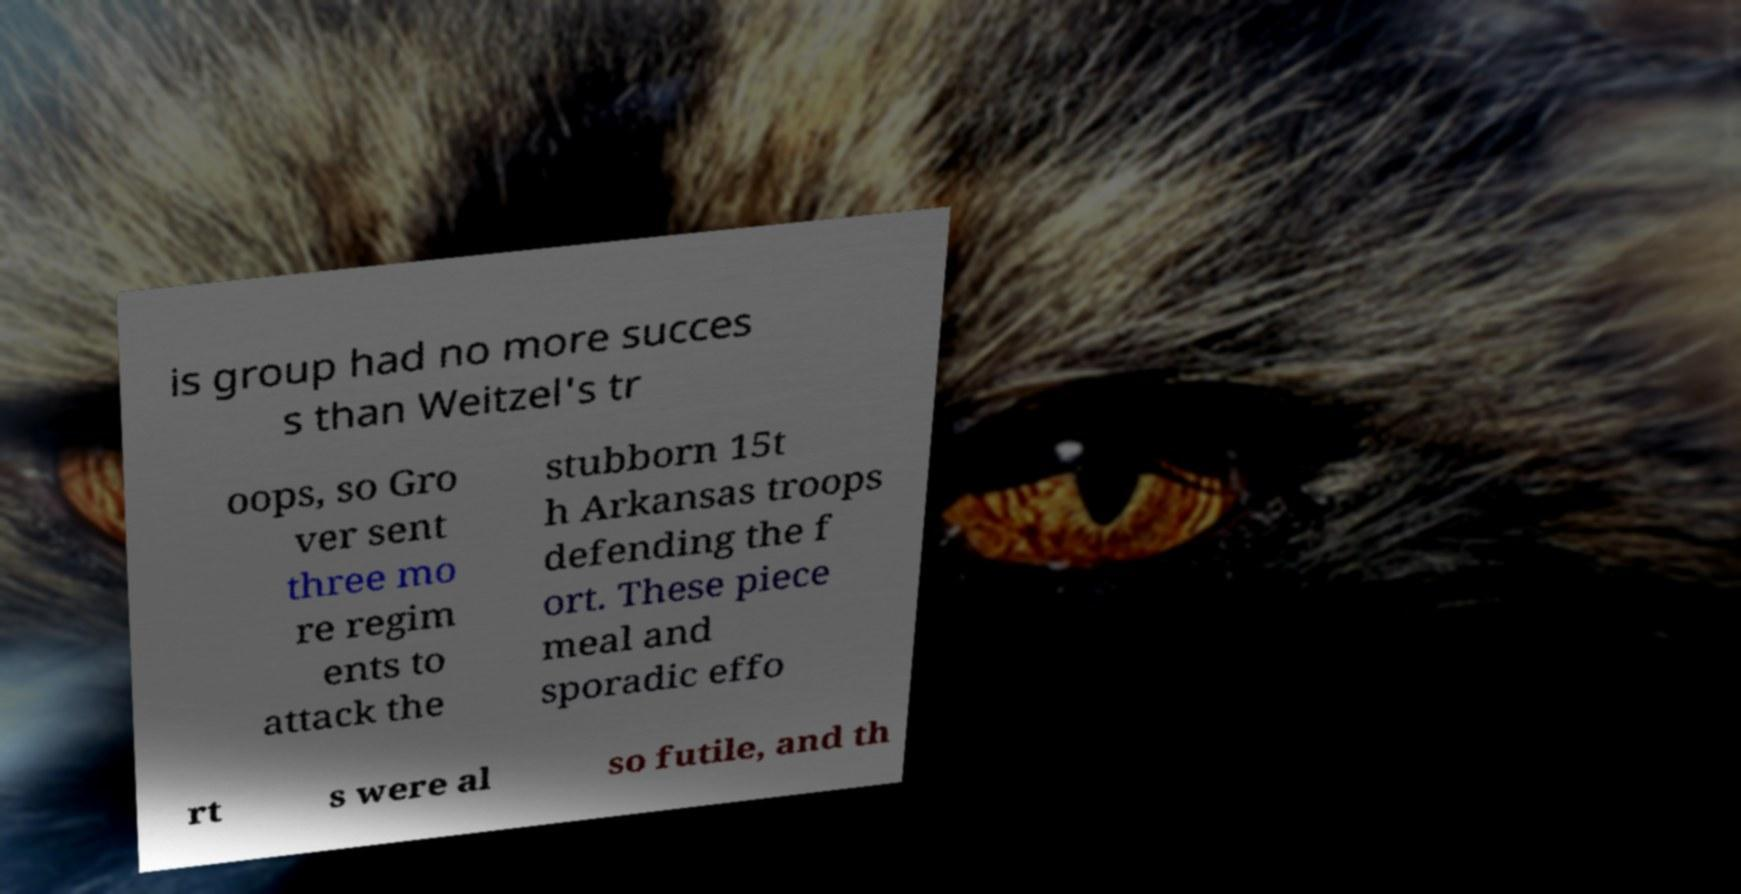Could you extract and type out the text from this image? is group had no more succes s than Weitzel's tr oops, so Gro ver sent three mo re regim ents to attack the stubborn 15t h Arkansas troops defending the f ort. These piece meal and sporadic effo rt s were al so futile, and th 